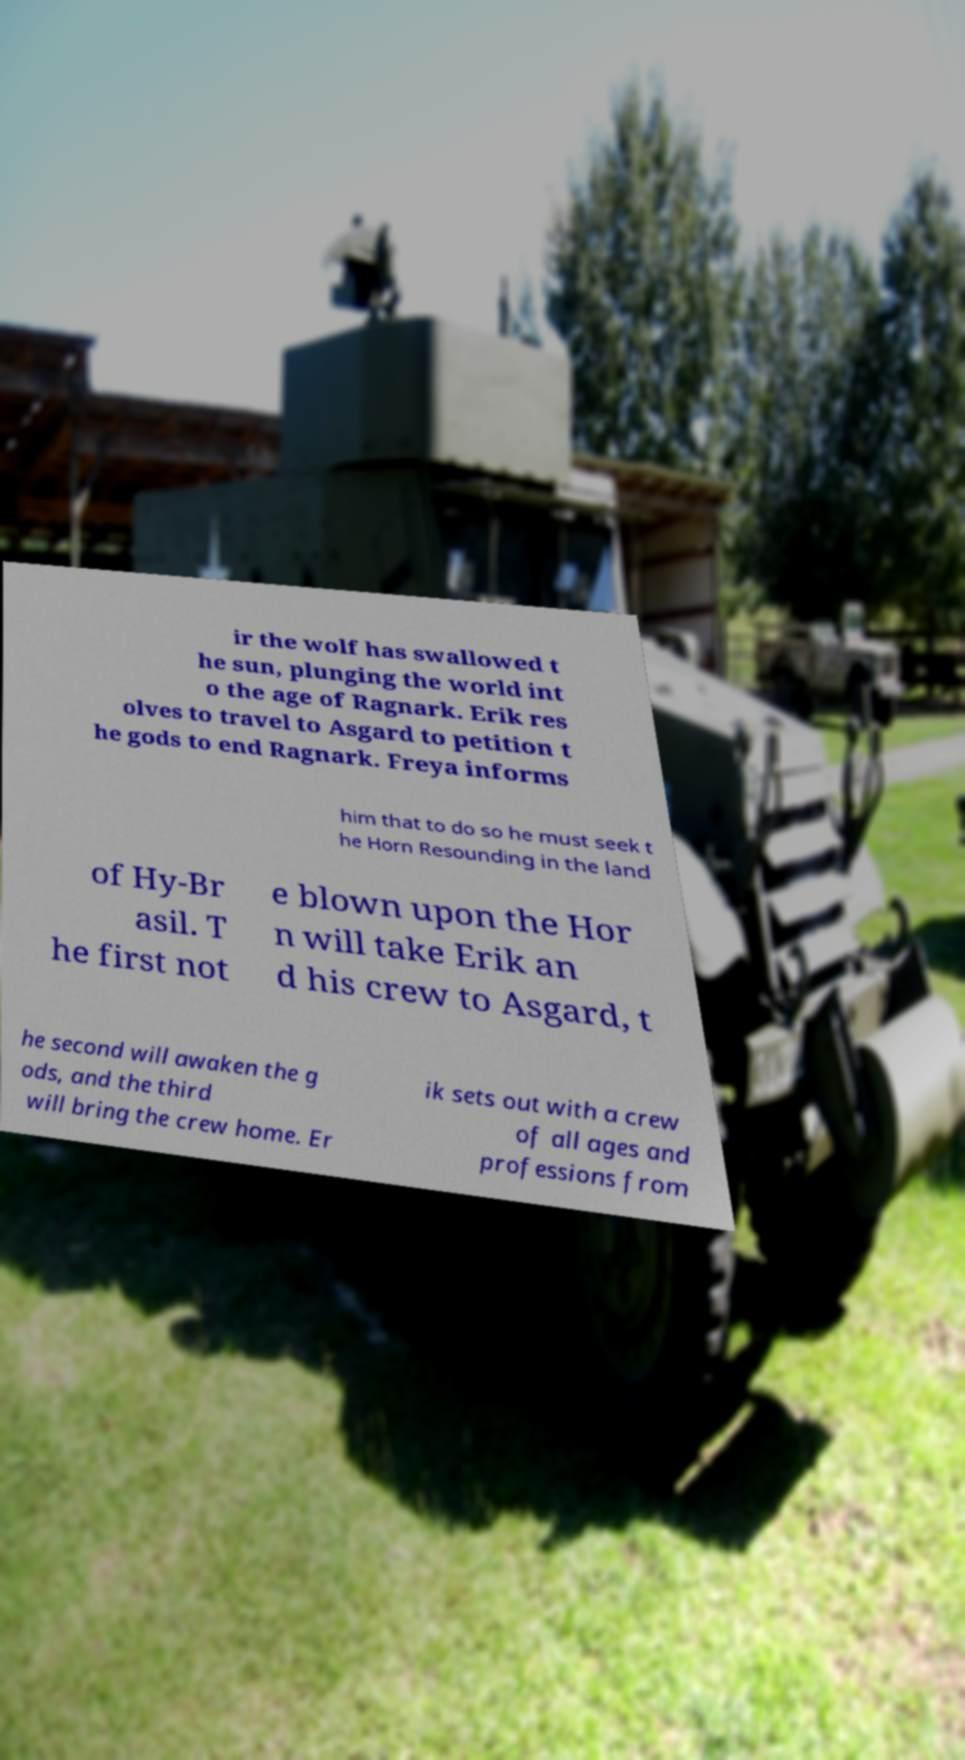Can you read and provide the text displayed in the image?This photo seems to have some interesting text. Can you extract and type it out for me? ir the wolf has swallowed t he sun, plunging the world int o the age of Ragnark. Erik res olves to travel to Asgard to petition t he gods to end Ragnark. Freya informs him that to do so he must seek t he Horn Resounding in the land of Hy-Br asil. T he first not e blown upon the Hor n will take Erik an d his crew to Asgard, t he second will awaken the g ods, and the third will bring the crew home. Er ik sets out with a crew of all ages and professions from 